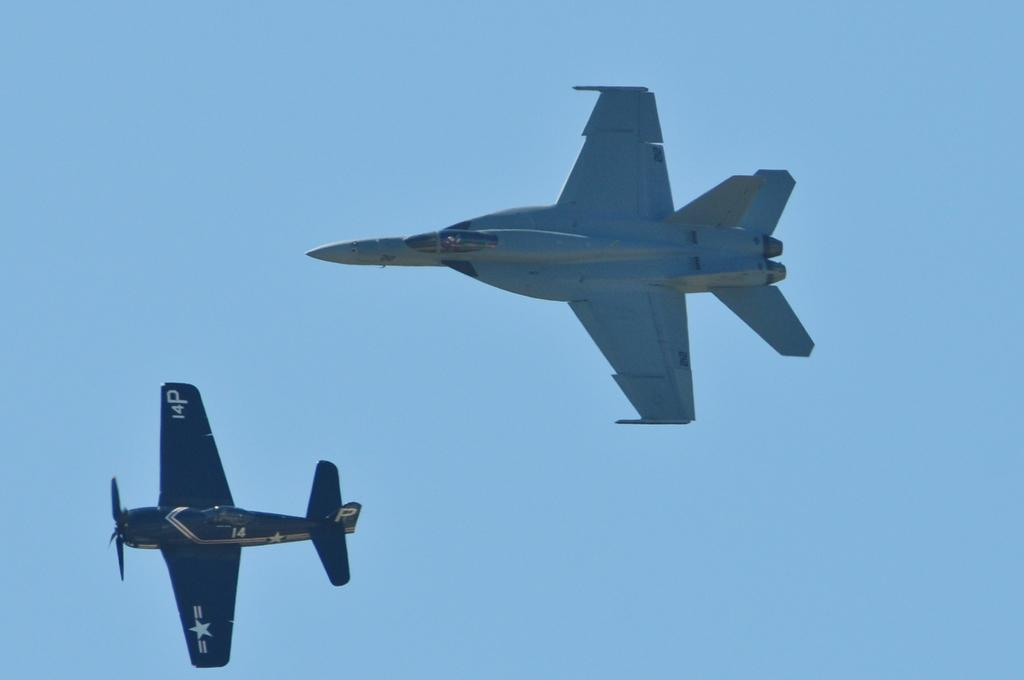What type of planes are visible in the image? There is a training plane and a fighter jet in the image. What are the planes doing in the image? Both planes are flying in the sky. What is the color of the sky in the image? The sky is blue in the image. What language is being spoken by the horse in the image? There is no horse present in the image, and therefore no language being spoken. 